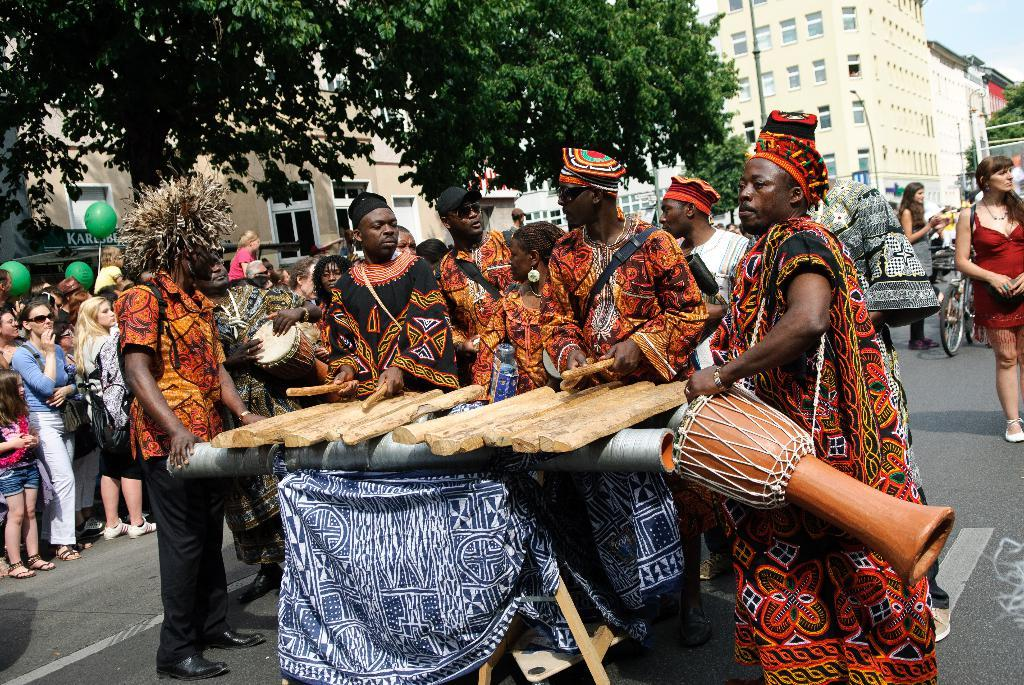What are the people in the image doing? There are persons standing on the road in the image. What else can be seen in the image besides the people? There are balloons in the image. What can be seen in the background of the image? There are buildings and trees in the background of the image. What is visible at the top of the image? The sky is visible in the image. Can you see a ship sailing in the sky in the image? No, there is no ship visible in the image. Where is the kitten playing in the image? There is no kitten present in the image. 